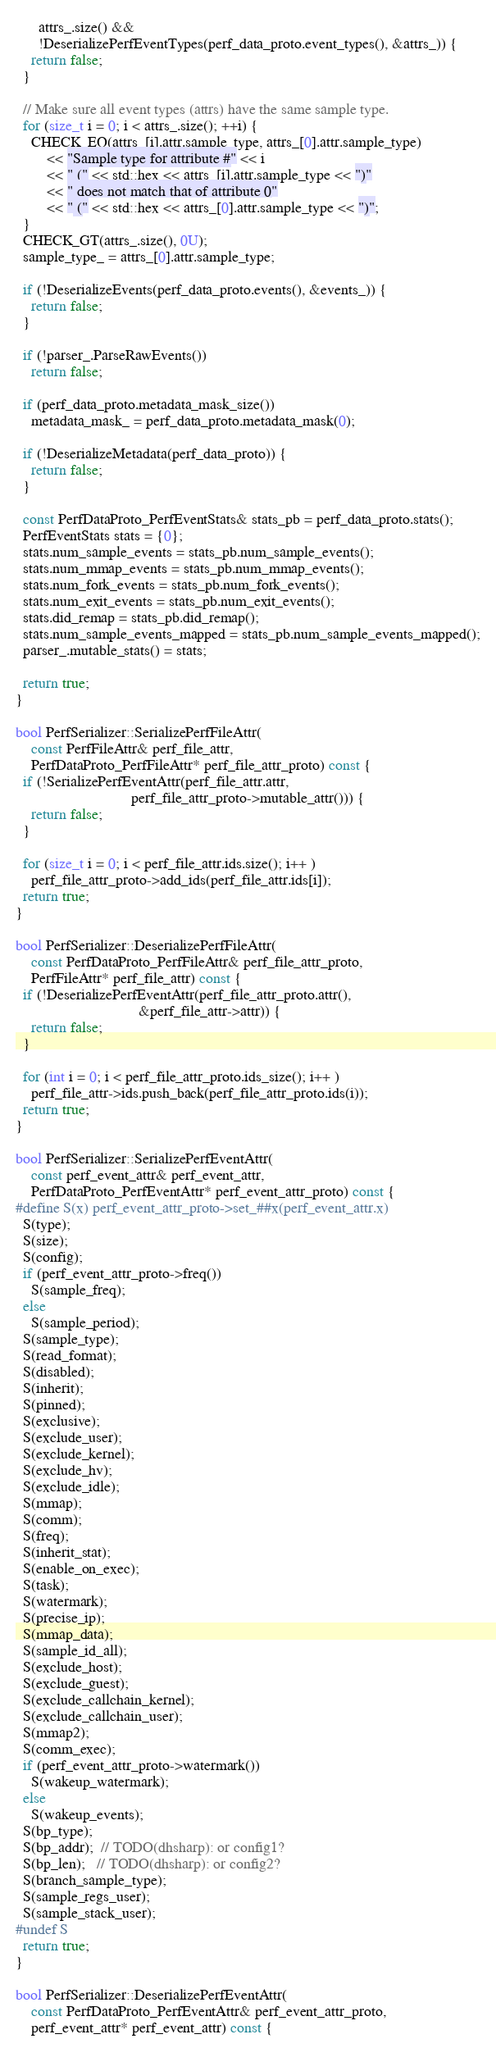Convert code to text. <code><loc_0><loc_0><loc_500><loc_500><_C++_>      attrs_.size() &&
      !DeserializePerfEventTypes(perf_data_proto.event_types(), &attrs_)) {
    return false;
  }

  // Make sure all event types (attrs) have the same sample type.
  for (size_t i = 0; i < attrs_.size(); ++i) {
    CHECK_EQ(attrs_[i].attr.sample_type, attrs_[0].attr.sample_type)
        << "Sample type for attribute #" << i
        << " (" << std::hex << attrs_[i].attr.sample_type << ")"
        << " does not match that of attribute 0"
        << " (" << std::hex << attrs_[0].attr.sample_type << ")";
  }
  CHECK_GT(attrs_.size(), 0U);
  sample_type_ = attrs_[0].attr.sample_type;

  if (!DeserializeEvents(perf_data_proto.events(), &events_)) {
    return false;
  }

  if (!parser_.ParseRawEvents())
    return false;

  if (perf_data_proto.metadata_mask_size())
    metadata_mask_ = perf_data_proto.metadata_mask(0);

  if (!DeserializeMetadata(perf_data_proto)) {
    return false;
  }

  const PerfDataProto_PerfEventStats& stats_pb = perf_data_proto.stats();
  PerfEventStats stats = {0};
  stats.num_sample_events = stats_pb.num_sample_events();
  stats.num_mmap_events = stats_pb.num_mmap_events();
  stats.num_fork_events = stats_pb.num_fork_events();
  stats.num_exit_events = stats_pb.num_exit_events();
  stats.did_remap = stats_pb.did_remap();
  stats.num_sample_events_mapped = stats_pb.num_sample_events_mapped();
  parser_.mutable_stats() = stats;

  return true;
}

bool PerfSerializer::SerializePerfFileAttr(
    const PerfFileAttr& perf_file_attr,
    PerfDataProto_PerfFileAttr* perf_file_attr_proto) const {
  if (!SerializePerfEventAttr(perf_file_attr.attr,
                              perf_file_attr_proto->mutable_attr())) {
    return false;
  }

  for (size_t i = 0; i < perf_file_attr.ids.size(); i++ )
    perf_file_attr_proto->add_ids(perf_file_attr.ids[i]);
  return true;
}

bool PerfSerializer::DeserializePerfFileAttr(
    const PerfDataProto_PerfFileAttr& perf_file_attr_proto,
    PerfFileAttr* perf_file_attr) const {
  if (!DeserializePerfEventAttr(perf_file_attr_proto.attr(),
                                &perf_file_attr->attr)) {
    return false;
  }

  for (int i = 0; i < perf_file_attr_proto.ids_size(); i++ )
    perf_file_attr->ids.push_back(perf_file_attr_proto.ids(i));
  return true;
}

bool PerfSerializer::SerializePerfEventAttr(
    const perf_event_attr& perf_event_attr,
    PerfDataProto_PerfEventAttr* perf_event_attr_proto) const {
#define S(x) perf_event_attr_proto->set_##x(perf_event_attr.x)
  S(type);
  S(size);
  S(config);
  if (perf_event_attr_proto->freq())
    S(sample_freq);
  else
    S(sample_period);
  S(sample_type);
  S(read_format);
  S(disabled);
  S(inherit);
  S(pinned);
  S(exclusive);
  S(exclude_user);
  S(exclude_kernel);
  S(exclude_hv);
  S(exclude_idle);
  S(mmap);
  S(comm);
  S(freq);
  S(inherit_stat);
  S(enable_on_exec);
  S(task);
  S(watermark);
  S(precise_ip);
  S(mmap_data);
  S(sample_id_all);
  S(exclude_host);
  S(exclude_guest);
  S(exclude_callchain_kernel);
  S(exclude_callchain_user);
  S(mmap2);
  S(comm_exec);
  if (perf_event_attr_proto->watermark())
    S(wakeup_watermark);
  else
    S(wakeup_events);
  S(bp_type);
  S(bp_addr);  // TODO(dhsharp): or config1?
  S(bp_len);   // TODO(dhsharp): or config2?
  S(branch_sample_type);
  S(sample_regs_user);
  S(sample_stack_user);
#undef S
  return true;
}

bool PerfSerializer::DeserializePerfEventAttr(
    const PerfDataProto_PerfEventAttr& perf_event_attr_proto,
    perf_event_attr* perf_event_attr) const {</code> 